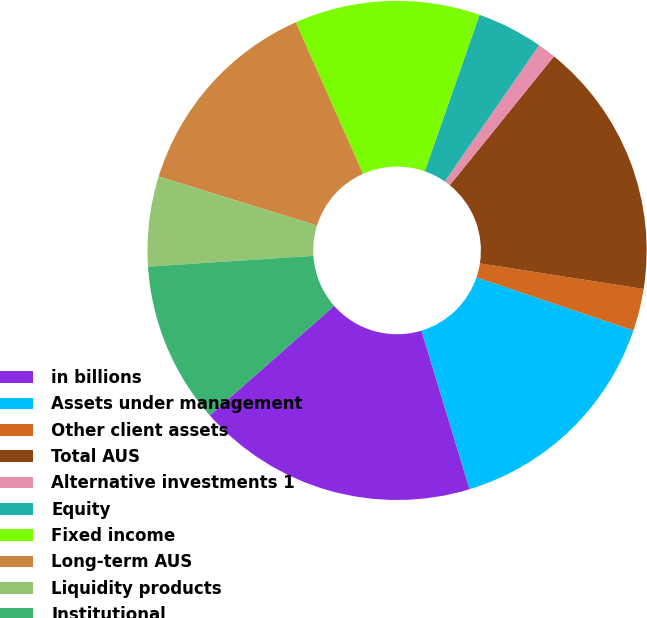Convert chart. <chart><loc_0><loc_0><loc_500><loc_500><pie_chart><fcel>in billions<fcel>Assets under management<fcel>Other client assets<fcel>Total AUS<fcel>Alternative investments 1<fcel>Equity<fcel>Fixed income<fcel>Long-term AUS<fcel>Liquidity products<fcel>Institutional<nl><fcel>18.2%<fcel>15.1%<fcel>2.73%<fcel>16.65%<fcel>1.18%<fcel>4.28%<fcel>12.01%<fcel>13.56%<fcel>5.82%<fcel>10.46%<nl></chart> 